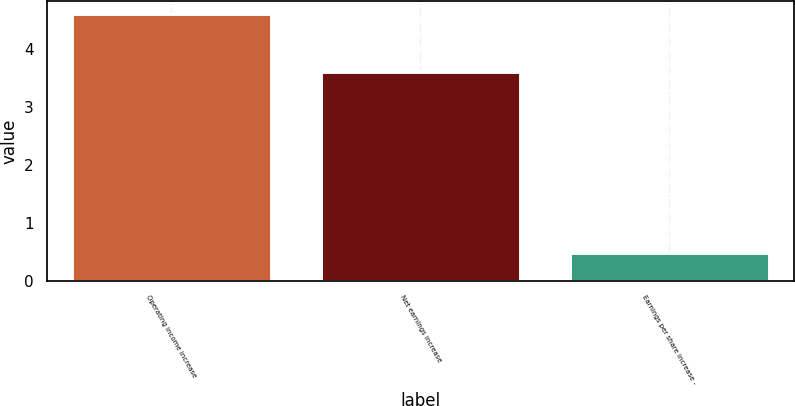Convert chart. <chart><loc_0><loc_0><loc_500><loc_500><bar_chart><fcel>Operating income increase<fcel>Net earnings increase<fcel>Earnings per share increase -<nl><fcel>4.6<fcel>3.6<fcel>0.49<nl></chart> 